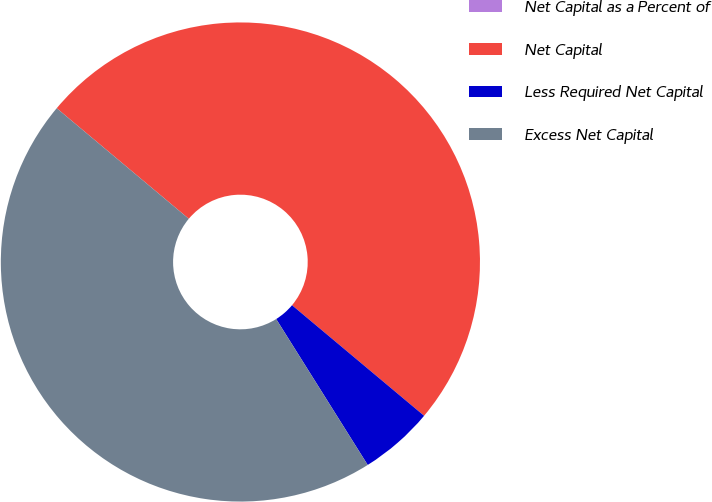<chart> <loc_0><loc_0><loc_500><loc_500><pie_chart><fcel>Net Capital as a Percent of<fcel>Net Capital<fcel>Less Required Net Capital<fcel>Excess Net Capital<nl><fcel>0.0%<fcel>50.0%<fcel>4.99%<fcel>45.01%<nl></chart> 